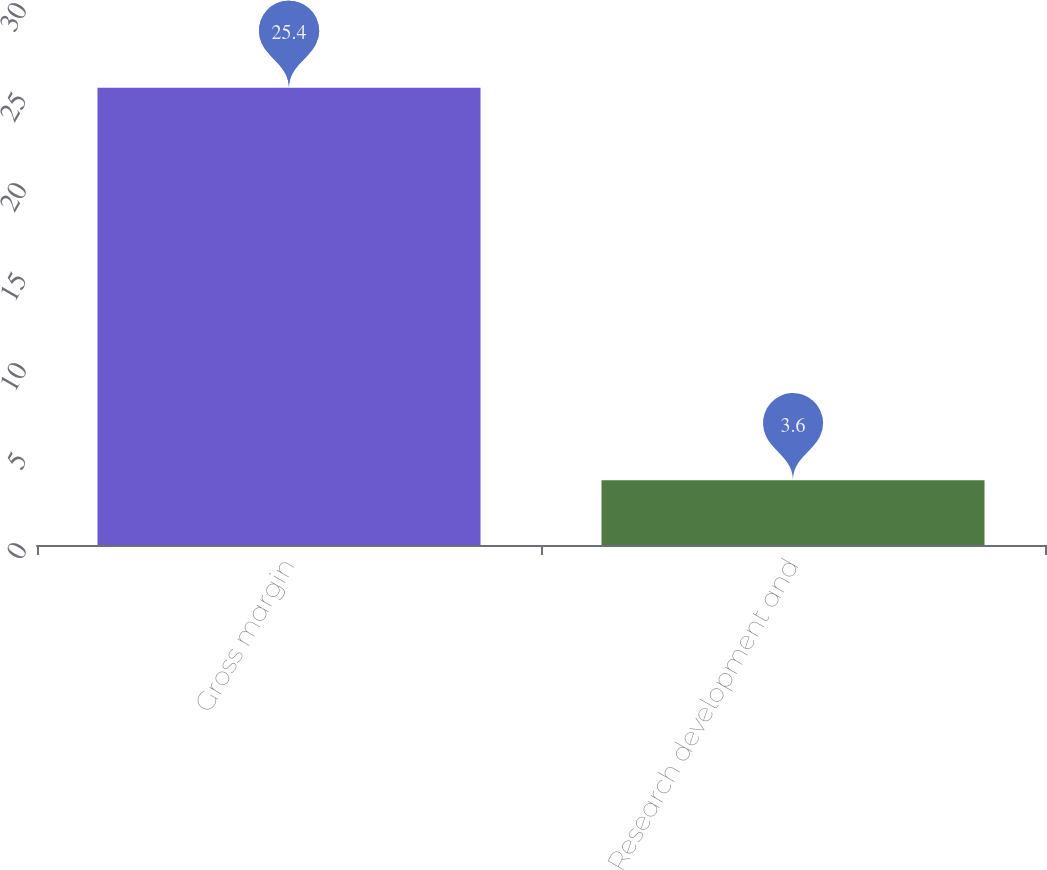Convert chart. <chart><loc_0><loc_0><loc_500><loc_500><bar_chart><fcel>Gross margin<fcel>Research development and<nl><fcel>25.4<fcel>3.6<nl></chart> 